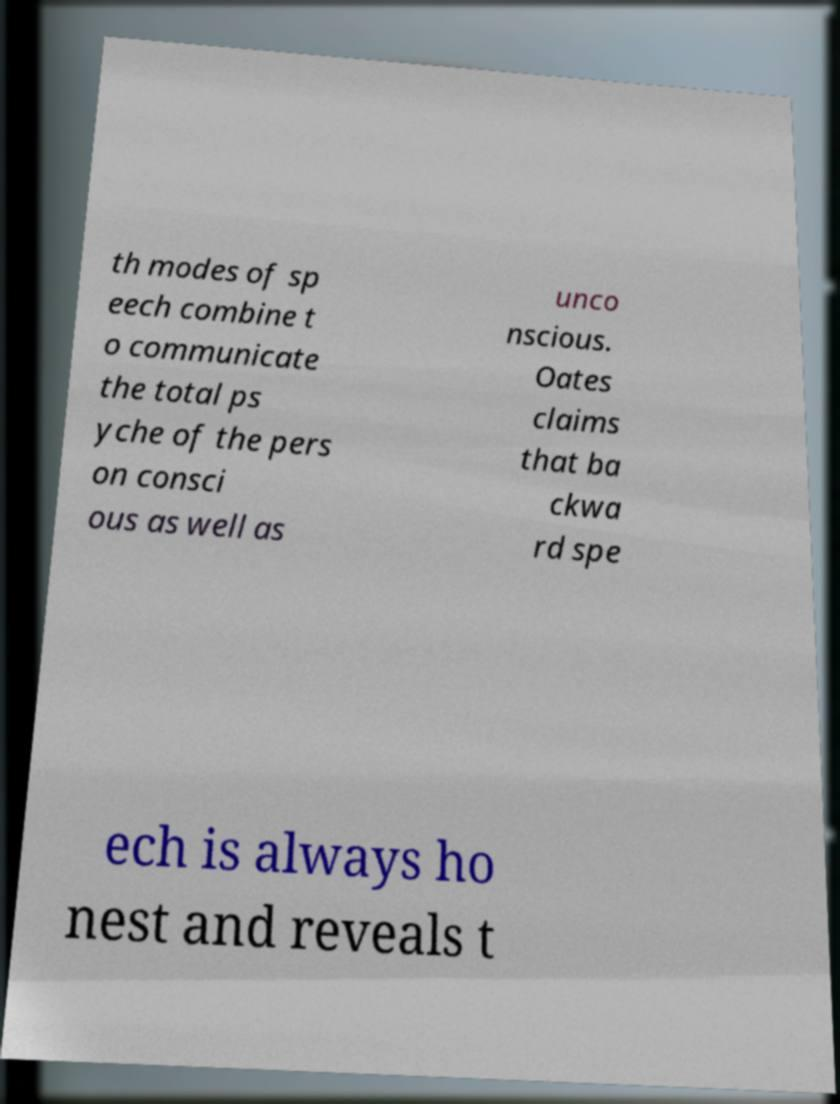Please read and relay the text visible in this image. What does it say? th modes of sp eech combine t o communicate the total ps yche of the pers on consci ous as well as unco nscious. Oates claims that ba ckwa rd spe ech is always ho nest and reveals t 